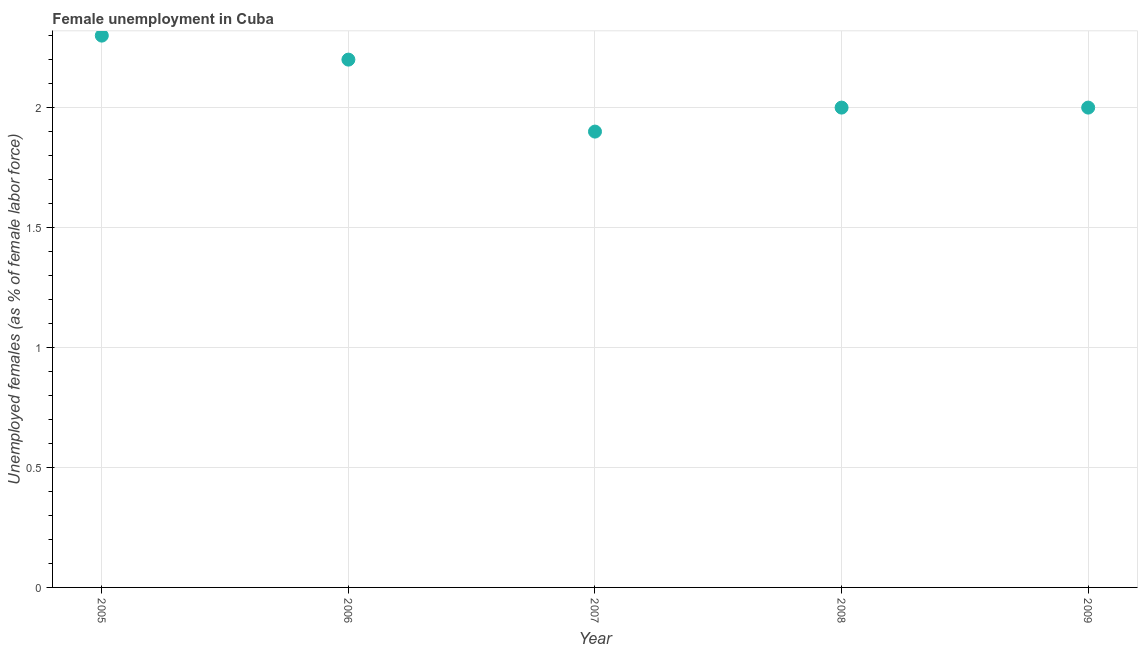What is the unemployed females population in 2005?
Your answer should be very brief. 2.3. Across all years, what is the maximum unemployed females population?
Make the answer very short. 2.3. Across all years, what is the minimum unemployed females population?
Ensure brevity in your answer.  1.9. In which year was the unemployed females population maximum?
Your response must be concise. 2005. In which year was the unemployed females population minimum?
Offer a terse response. 2007. What is the sum of the unemployed females population?
Provide a short and direct response. 10.4. What is the difference between the unemployed females population in 2006 and 2008?
Make the answer very short. 0.2. What is the average unemployed females population per year?
Your answer should be compact. 2.08. In how many years, is the unemployed females population greater than 0.1 %?
Provide a short and direct response. 5. Do a majority of the years between 2005 and 2007 (inclusive) have unemployed females population greater than 0.5 %?
Your answer should be compact. Yes. What is the ratio of the unemployed females population in 2006 to that in 2008?
Ensure brevity in your answer.  1.1. Is the difference between the unemployed females population in 2005 and 2008 greater than the difference between any two years?
Your answer should be very brief. No. What is the difference between the highest and the second highest unemployed females population?
Your answer should be compact. 0.1. What is the difference between the highest and the lowest unemployed females population?
Offer a terse response. 0.4. In how many years, is the unemployed females population greater than the average unemployed females population taken over all years?
Provide a succinct answer. 2. How many dotlines are there?
Your answer should be very brief. 1. How many years are there in the graph?
Your answer should be very brief. 5. Are the values on the major ticks of Y-axis written in scientific E-notation?
Offer a very short reply. No. What is the title of the graph?
Offer a terse response. Female unemployment in Cuba. What is the label or title of the Y-axis?
Your answer should be compact. Unemployed females (as % of female labor force). What is the Unemployed females (as % of female labor force) in 2005?
Offer a terse response. 2.3. What is the Unemployed females (as % of female labor force) in 2006?
Provide a succinct answer. 2.2. What is the Unemployed females (as % of female labor force) in 2007?
Your response must be concise. 1.9. What is the difference between the Unemployed females (as % of female labor force) in 2005 and 2008?
Give a very brief answer. 0.3. What is the difference between the Unemployed females (as % of female labor force) in 2005 and 2009?
Make the answer very short. 0.3. What is the difference between the Unemployed females (as % of female labor force) in 2006 and 2007?
Ensure brevity in your answer.  0.3. What is the difference between the Unemployed females (as % of female labor force) in 2006 and 2008?
Your response must be concise. 0.2. What is the difference between the Unemployed females (as % of female labor force) in 2008 and 2009?
Your answer should be compact. 0. What is the ratio of the Unemployed females (as % of female labor force) in 2005 to that in 2006?
Make the answer very short. 1.04. What is the ratio of the Unemployed females (as % of female labor force) in 2005 to that in 2007?
Ensure brevity in your answer.  1.21. What is the ratio of the Unemployed females (as % of female labor force) in 2005 to that in 2008?
Provide a succinct answer. 1.15. What is the ratio of the Unemployed females (as % of female labor force) in 2005 to that in 2009?
Provide a short and direct response. 1.15. What is the ratio of the Unemployed females (as % of female labor force) in 2006 to that in 2007?
Make the answer very short. 1.16. What is the ratio of the Unemployed females (as % of female labor force) in 2006 to that in 2008?
Provide a succinct answer. 1.1. What is the ratio of the Unemployed females (as % of female labor force) in 2006 to that in 2009?
Make the answer very short. 1.1. What is the ratio of the Unemployed females (as % of female labor force) in 2007 to that in 2008?
Provide a short and direct response. 0.95. 